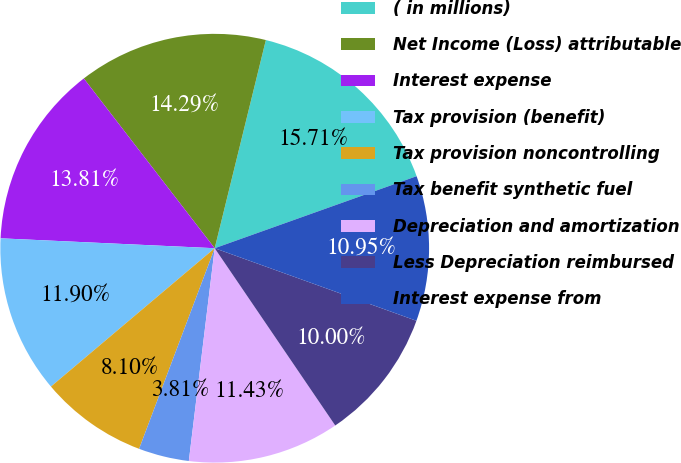<chart> <loc_0><loc_0><loc_500><loc_500><pie_chart><fcel>( in millions)<fcel>Net Income (Loss) attributable<fcel>Interest expense<fcel>Tax provision (benefit)<fcel>Tax provision noncontrolling<fcel>Tax benefit synthetic fuel<fcel>Depreciation and amortization<fcel>Less Depreciation reimbursed<fcel>Interest expense from<nl><fcel>15.71%<fcel>14.29%<fcel>13.81%<fcel>11.9%<fcel>8.1%<fcel>3.81%<fcel>11.43%<fcel>10.0%<fcel>10.95%<nl></chart> 